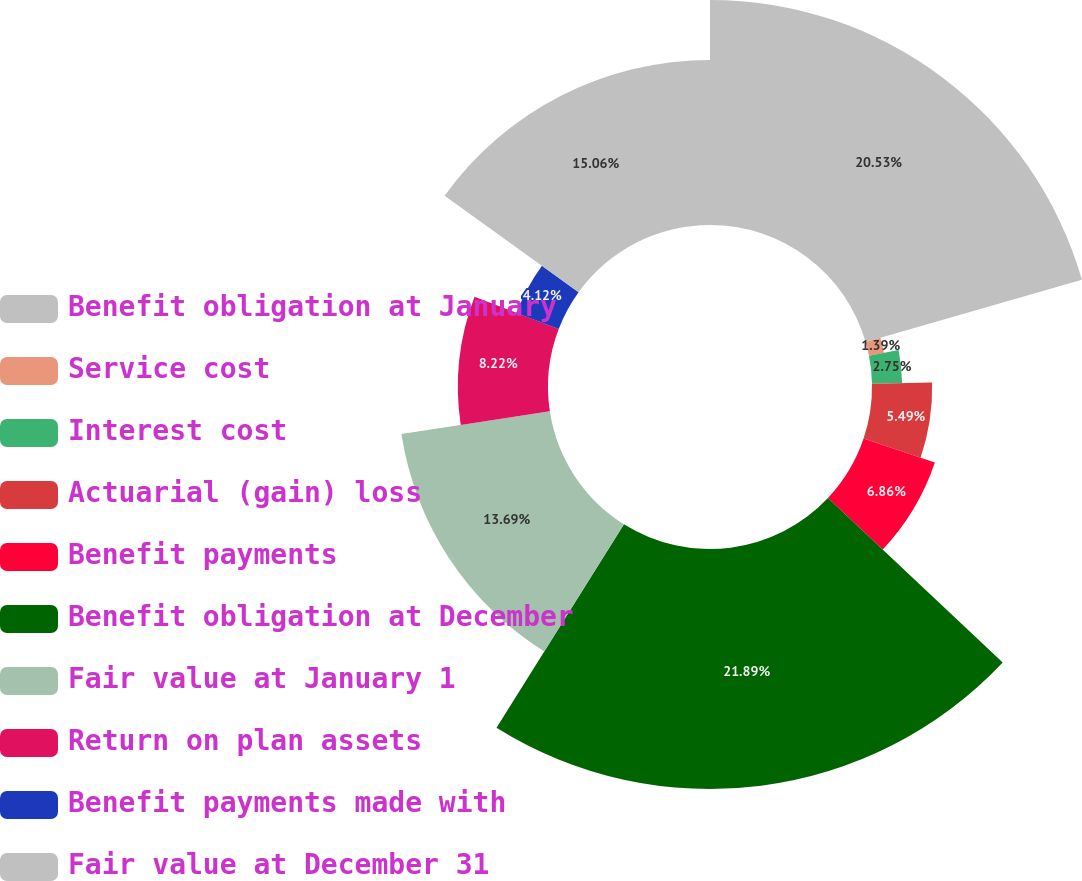Convert chart to OTSL. <chart><loc_0><loc_0><loc_500><loc_500><pie_chart><fcel>Benefit obligation at January<fcel>Service cost<fcel>Interest cost<fcel>Actuarial (gain) loss<fcel>Benefit payments<fcel>Benefit obligation at December<fcel>Fair value at January 1<fcel>Return on plan assets<fcel>Benefit payments made with<fcel>Fair value at December 31<nl><fcel>20.53%<fcel>1.39%<fcel>2.75%<fcel>5.49%<fcel>6.86%<fcel>21.89%<fcel>13.69%<fcel>8.22%<fcel>4.12%<fcel>15.06%<nl></chart> 